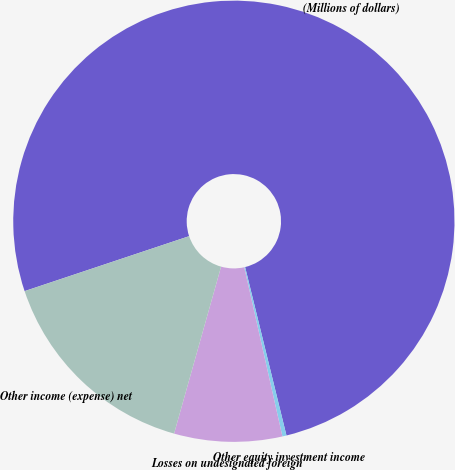Convert chart. <chart><loc_0><loc_0><loc_500><loc_500><pie_chart><fcel>(Millions of dollars)<fcel>Other equity investment income<fcel>Losses on undesignated foreign<fcel>Other income (expense) net<nl><fcel>76.29%<fcel>0.3%<fcel>7.9%<fcel>15.5%<nl></chart> 